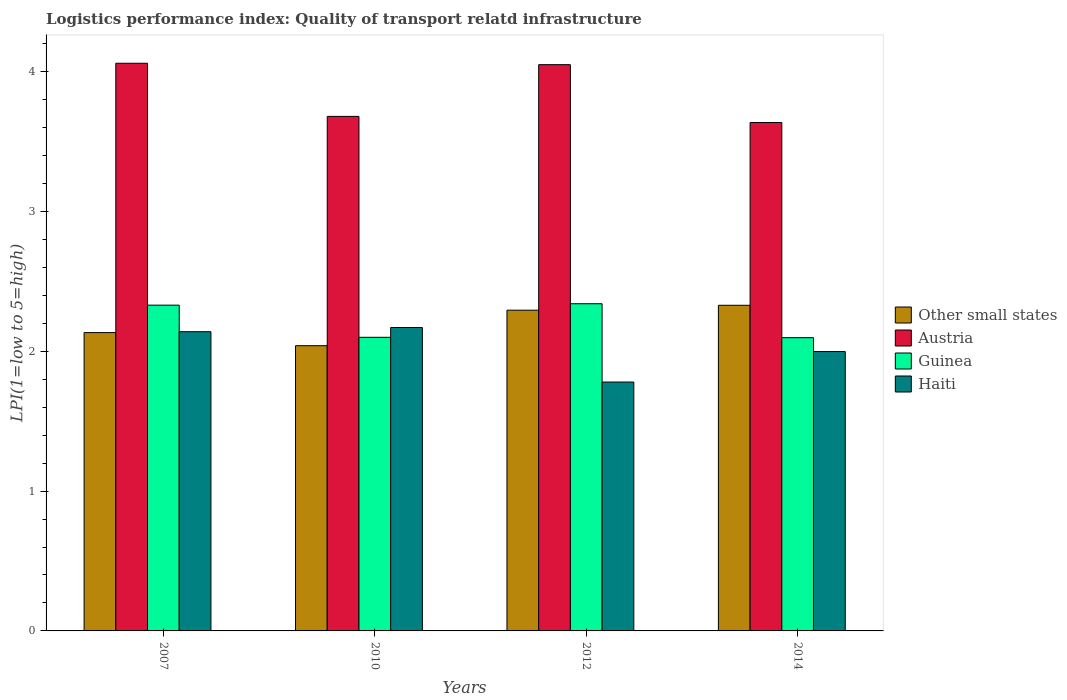How many different coloured bars are there?
Offer a very short reply. 4. How many groups of bars are there?
Keep it short and to the point. 4. Are the number of bars per tick equal to the number of legend labels?
Provide a short and direct response. Yes. Are the number of bars on each tick of the X-axis equal?
Offer a terse response. Yes. How many bars are there on the 4th tick from the left?
Offer a terse response. 4. What is the label of the 3rd group of bars from the left?
Make the answer very short. 2012. In how many cases, is the number of bars for a given year not equal to the number of legend labels?
Your response must be concise. 0. What is the logistics performance index in Austria in 2010?
Keep it short and to the point. 3.68. Across all years, what is the maximum logistics performance index in Austria?
Keep it short and to the point. 4.06. Across all years, what is the minimum logistics performance index in Haiti?
Give a very brief answer. 1.78. In which year was the logistics performance index in Austria maximum?
Give a very brief answer. 2007. What is the total logistics performance index in Austria in the graph?
Offer a terse response. 15.43. What is the difference between the logistics performance index in Other small states in 2007 and that in 2012?
Your answer should be very brief. -0.16. What is the difference between the logistics performance index in Haiti in 2007 and the logistics performance index in Other small states in 2010?
Your answer should be compact. 0.1. What is the average logistics performance index in Austria per year?
Your response must be concise. 3.86. In the year 2007, what is the difference between the logistics performance index in Guinea and logistics performance index in Haiti?
Offer a terse response. 0.19. In how many years, is the logistics performance index in Austria greater than 3.6?
Provide a succinct answer. 4. What is the ratio of the logistics performance index in Haiti in 2010 to that in 2012?
Your answer should be compact. 1.22. Is the logistics performance index in Haiti in 2007 less than that in 2012?
Your response must be concise. No. Is the difference between the logistics performance index in Guinea in 2010 and 2012 greater than the difference between the logistics performance index in Haiti in 2010 and 2012?
Offer a very short reply. No. What is the difference between the highest and the second highest logistics performance index in Haiti?
Provide a succinct answer. 0.03. What is the difference between the highest and the lowest logistics performance index in Haiti?
Offer a very short reply. 0.39. In how many years, is the logistics performance index in Haiti greater than the average logistics performance index in Haiti taken over all years?
Offer a terse response. 2. Is it the case that in every year, the sum of the logistics performance index in Haiti and logistics performance index in Guinea is greater than the sum of logistics performance index in Austria and logistics performance index in Other small states?
Your answer should be very brief. Yes. What does the 3rd bar from the left in 2010 represents?
Offer a very short reply. Guinea. What does the 1st bar from the right in 2014 represents?
Provide a short and direct response. Haiti. Is it the case that in every year, the sum of the logistics performance index in Guinea and logistics performance index in Haiti is greater than the logistics performance index in Other small states?
Give a very brief answer. Yes. Does the graph contain any zero values?
Your answer should be very brief. No. Where does the legend appear in the graph?
Provide a short and direct response. Center right. How many legend labels are there?
Make the answer very short. 4. How are the legend labels stacked?
Ensure brevity in your answer.  Vertical. What is the title of the graph?
Your answer should be very brief. Logistics performance index: Quality of transport relatd infrastructure. Does "Saudi Arabia" appear as one of the legend labels in the graph?
Offer a very short reply. No. What is the label or title of the Y-axis?
Your answer should be very brief. LPI(1=low to 5=high). What is the LPI(1=low to 5=high) of Other small states in 2007?
Make the answer very short. 2.13. What is the LPI(1=low to 5=high) in Austria in 2007?
Ensure brevity in your answer.  4.06. What is the LPI(1=low to 5=high) in Guinea in 2007?
Ensure brevity in your answer.  2.33. What is the LPI(1=low to 5=high) in Haiti in 2007?
Your answer should be compact. 2.14. What is the LPI(1=low to 5=high) in Other small states in 2010?
Your answer should be very brief. 2.04. What is the LPI(1=low to 5=high) in Austria in 2010?
Offer a very short reply. 3.68. What is the LPI(1=low to 5=high) in Haiti in 2010?
Keep it short and to the point. 2.17. What is the LPI(1=low to 5=high) of Other small states in 2012?
Offer a terse response. 2.29. What is the LPI(1=low to 5=high) in Austria in 2012?
Ensure brevity in your answer.  4.05. What is the LPI(1=low to 5=high) of Guinea in 2012?
Give a very brief answer. 2.34. What is the LPI(1=low to 5=high) in Haiti in 2012?
Offer a terse response. 1.78. What is the LPI(1=low to 5=high) in Other small states in 2014?
Keep it short and to the point. 2.33. What is the LPI(1=low to 5=high) in Austria in 2014?
Your answer should be very brief. 3.64. What is the LPI(1=low to 5=high) in Guinea in 2014?
Make the answer very short. 2.1. What is the LPI(1=low to 5=high) in Haiti in 2014?
Your response must be concise. 2. Across all years, what is the maximum LPI(1=low to 5=high) of Other small states?
Your response must be concise. 2.33. Across all years, what is the maximum LPI(1=low to 5=high) in Austria?
Give a very brief answer. 4.06. Across all years, what is the maximum LPI(1=low to 5=high) in Guinea?
Ensure brevity in your answer.  2.34. Across all years, what is the maximum LPI(1=low to 5=high) of Haiti?
Offer a very short reply. 2.17. Across all years, what is the minimum LPI(1=low to 5=high) of Other small states?
Provide a succinct answer. 2.04. Across all years, what is the minimum LPI(1=low to 5=high) in Austria?
Ensure brevity in your answer.  3.64. Across all years, what is the minimum LPI(1=low to 5=high) of Guinea?
Offer a terse response. 2.1. Across all years, what is the minimum LPI(1=low to 5=high) of Haiti?
Provide a short and direct response. 1.78. What is the total LPI(1=low to 5=high) in Other small states in the graph?
Offer a very short reply. 8.8. What is the total LPI(1=low to 5=high) of Austria in the graph?
Offer a terse response. 15.43. What is the total LPI(1=low to 5=high) in Guinea in the graph?
Ensure brevity in your answer.  8.87. What is the total LPI(1=low to 5=high) in Haiti in the graph?
Provide a short and direct response. 8.09. What is the difference between the LPI(1=low to 5=high) in Other small states in 2007 and that in 2010?
Your answer should be very brief. 0.09. What is the difference between the LPI(1=low to 5=high) of Austria in 2007 and that in 2010?
Offer a terse response. 0.38. What is the difference between the LPI(1=low to 5=high) of Guinea in 2007 and that in 2010?
Make the answer very short. 0.23. What is the difference between the LPI(1=low to 5=high) in Haiti in 2007 and that in 2010?
Offer a very short reply. -0.03. What is the difference between the LPI(1=low to 5=high) in Other small states in 2007 and that in 2012?
Your response must be concise. -0.16. What is the difference between the LPI(1=low to 5=high) of Austria in 2007 and that in 2012?
Ensure brevity in your answer.  0.01. What is the difference between the LPI(1=low to 5=high) of Guinea in 2007 and that in 2012?
Make the answer very short. -0.01. What is the difference between the LPI(1=low to 5=high) in Haiti in 2007 and that in 2012?
Provide a short and direct response. 0.36. What is the difference between the LPI(1=low to 5=high) of Other small states in 2007 and that in 2014?
Ensure brevity in your answer.  -0.2. What is the difference between the LPI(1=low to 5=high) in Austria in 2007 and that in 2014?
Provide a short and direct response. 0.42. What is the difference between the LPI(1=low to 5=high) in Guinea in 2007 and that in 2014?
Provide a succinct answer. 0.23. What is the difference between the LPI(1=low to 5=high) of Haiti in 2007 and that in 2014?
Give a very brief answer. 0.14. What is the difference between the LPI(1=low to 5=high) of Other small states in 2010 and that in 2012?
Your response must be concise. -0.25. What is the difference between the LPI(1=low to 5=high) of Austria in 2010 and that in 2012?
Ensure brevity in your answer.  -0.37. What is the difference between the LPI(1=low to 5=high) in Guinea in 2010 and that in 2012?
Your answer should be compact. -0.24. What is the difference between the LPI(1=low to 5=high) of Haiti in 2010 and that in 2012?
Your response must be concise. 0.39. What is the difference between the LPI(1=low to 5=high) in Other small states in 2010 and that in 2014?
Offer a very short reply. -0.29. What is the difference between the LPI(1=low to 5=high) of Austria in 2010 and that in 2014?
Keep it short and to the point. 0.04. What is the difference between the LPI(1=low to 5=high) of Guinea in 2010 and that in 2014?
Your answer should be very brief. 0. What is the difference between the LPI(1=low to 5=high) in Haiti in 2010 and that in 2014?
Your answer should be very brief. 0.17. What is the difference between the LPI(1=low to 5=high) of Other small states in 2012 and that in 2014?
Offer a very short reply. -0.04. What is the difference between the LPI(1=low to 5=high) in Austria in 2012 and that in 2014?
Provide a short and direct response. 0.41. What is the difference between the LPI(1=low to 5=high) in Guinea in 2012 and that in 2014?
Provide a short and direct response. 0.24. What is the difference between the LPI(1=low to 5=high) of Haiti in 2012 and that in 2014?
Give a very brief answer. -0.22. What is the difference between the LPI(1=low to 5=high) in Other small states in 2007 and the LPI(1=low to 5=high) in Austria in 2010?
Make the answer very short. -1.55. What is the difference between the LPI(1=low to 5=high) in Other small states in 2007 and the LPI(1=low to 5=high) in Guinea in 2010?
Your answer should be very brief. 0.03. What is the difference between the LPI(1=low to 5=high) in Other small states in 2007 and the LPI(1=low to 5=high) in Haiti in 2010?
Make the answer very short. -0.04. What is the difference between the LPI(1=low to 5=high) in Austria in 2007 and the LPI(1=low to 5=high) in Guinea in 2010?
Your response must be concise. 1.96. What is the difference between the LPI(1=low to 5=high) of Austria in 2007 and the LPI(1=low to 5=high) of Haiti in 2010?
Your response must be concise. 1.89. What is the difference between the LPI(1=low to 5=high) in Guinea in 2007 and the LPI(1=low to 5=high) in Haiti in 2010?
Keep it short and to the point. 0.16. What is the difference between the LPI(1=low to 5=high) in Other small states in 2007 and the LPI(1=low to 5=high) in Austria in 2012?
Make the answer very short. -1.92. What is the difference between the LPI(1=low to 5=high) of Other small states in 2007 and the LPI(1=low to 5=high) of Guinea in 2012?
Offer a terse response. -0.21. What is the difference between the LPI(1=low to 5=high) of Other small states in 2007 and the LPI(1=low to 5=high) of Haiti in 2012?
Provide a short and direct response. 0.35. What is the difference between the LPI(1=low to 5=high) in Austria in 2007 and the LPI(1=low to 5=high) in Guinea in 2012?
Offer a very short reply. 1.72. What is the difference between the LPI(1=low to 5=high) in Austria in 2007 and the LPI(1=low to 5=high) in Haiti in 2012?
Your answer should be very brief. 2.28. What is the difference between the LPI(1=low to 5=high) of Guinea in 2007 and the LPI(1=low to 5=high) of Haiti in 2012?
Offer a terse response. 0.55. What is the difference between the LPI(1=low to 5=high) in Other small states in 2007 and the LPI(1=low to 5=high) in Austria in 2014?
Provide a succinct answer. -1.5. What is the difference between the LPI(1=low to 5=high) of Other small states in 2007 and the LPI(1=low to 5=high) of Guinea in 2014?
Make the answer very short. 0.04. What is the difference between the LPI(1=low to 5=high) of Other small states in 2007 and the LPI(1=low to 5=high) of Haiti in 2014?
Give a very brief answer. 0.14. What is the difference between the LPI(1=low to 5=high) in Austria in 2007 and the LPI(1=low to 5=high) in Guinea in 2014?
Your answer should be very brief. 1.96. What is the difference between the LPI(1=low to 5=high) in Austria in 2007 and the LPI(1=low to 5=high) in Haiti in 2014?
Ensure brevity in your answer.  2.06. What is the difference between the LPI(1=low to 5=high) of Guinea in 2007 and the LPI(1=low to 5=high) of Haiti in 2014?
Your answer should be compact. 0.33. What is the difference between the LPI(1=low to 5=high) of Other small states in 2010 and the LPI(1=low to 5=high) of Austria in 2012?
Your answer should be compact. -2.01. What is the difference between the LPI(1=low to 5=high) in Other small states in 2010 and the LPI(1=low to 5=high) in Guinea in 2012?
Your answer should be compact. -0.3. What is the difference between the LPI(1=low to 5=high) of Other small states in 2010 and the LPI(1=low to 5=high) of Haiti in 2012?
Your response must be concise. 0.26. What is the difference between the LPI(1=low to 5=high) in Austria in 2010 and the LPI(1=low to 5=high) in Guinea in 2012?
Your response must be concise. 1.34. What is the difference between the LPI(1=low to 5=high) of Austria in 2010 and the LPI(1=low to 5=high) of Haiti in 2012?
Ensure brevity in your answer.  1.9. What is the difference between the LPI(1=low to 5=high) of Guinea in 2010 and the LPI(1=low to 5=high) of Haiti in 2012?
Provide a short and direct response. 0.32. What is the difference between the LPI(1=low to 5=high) in Other small states in 2010 and the LPI(1=low to 5=high) in Austria in 2014?
Your response must be concise. -1.6. What is the difference between the LPI(1=low to 5=high) of Other small states in 2010 and the LPI(1=low to 5=high) of Guinea in 2014?
Offer a terse response. -0.06. What is the difference between the LPI(1=low to 5=high) in Other small states in 2010 and the LPI(1=low to 5=high) in Haiti in 2014?
Provide a succinct answer. 0.04. What is the difference between the LPI(1=low to 5=high) in Austria in 2010 and the LPI(1=low to 5=high) in Guinea in 2014?
Offer a terse response. 1.58. What is the difference between the LPI(1=low to 5=high) of Austria in 2010 and the LPI(1=low to 5=high) of Haiti in 2014?
Provide a short and direct response. 1.68. What is the difference between the LPI(1=low to 5=high) of Guinea in 2010 and the LPI(1=low to 5=high) of Haiti in 2014?
Make the answer very short. 0.1. What is the difference between the LPI(1=low to 5=high) in Other small states in 2012 and the LPI(1=low to 5=high) in Austria in 2014?
Your answer should be very brief. -1.34. What is the difference between the LPI(1=low to 5=high) in Other small states in 2012 and the LPI(1=low to 5=high) in Guinea in 2014?
Make the answer very short. 0.2. What is the difference between the LPI(1=low to 5=high) in Other small states in 2012 and the LPI(1=low to 5=high) in Haiti in 2014?
Give a very brief answer. 0.3. What is the difference between the LPI(1=low to 5=high) in Austria in 2012 and the LPI(1=low to 5=high) in Guinea in 2014?
Make the answer very short. 1.95. What is the difference between the LPI(1=low to 5=high) of Austria in 2012 and the LPI(1=low to 5=high) of Haiti in 2014?
Your answer should be compact. 2.05. What is the difference between the LPI(1=low to 5=high) in Guinea in 2012 and the LPI(1=low to 5=high) in Haiti in 2014?
Make the answer very short. 0.34. What is the average LPI(1=low to 5=high) of Other small states per year?
Your answer should be compact. 2.2. What is the average LPI(1=low to 5=high) in Austria per year?
Offer a terse response. 3.86. What is the average LPI(1=low to 5=high) of Guinea per year?
Provide a short and direct response. 2.22. What is the average LPI(1=low to 5=high) in Haiti per year?
Ensure brevity in your answer.  2.02. In the year 2007, what is the difference between the LPI(1=low to 5=high) in Other small states and LPI(1=low to 5=high) in Austria?
Ensure brevity in your answer.  -1.93. In the year 2007, what is the difference between the LPI(1=low to 5=high) in Other small states and LPI(1=low to 5=high) in Guinea?
Make the answer very short. -0.2. In the year 2007, what is the difference between the LPI(1=low to 5=high) in Other small states and LPI(1=low to 5=high) in Haiti?
Ensure brevity in your answer.  -0.01. In the year 2007, what is the difference between the LPI(1=low to 5=high) in Austria and LPI(1=low to 5=high) in Guinea?
Ensure brevity in your answer.  1.73. In the year 2007, what is the difference between the LPI(1=low to 5=high) in Austria and LPI(1=low to 5=high) in Haiti?
Provide a short and direct response. 1.92. In the year 2007, what is the difference between the LPI(1=low to 5=high) of Guinea and LPI(1=low to 5=high) of Haiti?
Your answer should be very brief. 0.19. In the year 2010, what is the difference between the LPI(1=low to 5=high) in Other small states and LPI(1=low to 5=high) in Austria?
Give a very brief answer. -1.64. In the year 2010, what is the difference between the LPI(1=low to 5=high) of Other small states and LPI(1=low to 5=high) of Guinea?
Your answer should be compact. -0.06. In the year 2010, what is the difference between the LPI(1=low to 5=high) of Other small states and LPI(1=low to 5=high) of Haiti?
Your response must be concise. -0.13. In the year 2010, what is the difference between the LPI(1=low to 5=high) in Austria and LPI(1=low to 5=high) in Guinea?
Your answer should be compact. 1.58. In the year 2010, what is the difference between the LPI(1=low to 5=high) of Austria and LPI(1=low to 5=high) of Haiti?
Offer a terse response. 1.51. In the year 2010, what is the difference between the LPI(1=low to 5=high) in Guinea and LPI(1=low to 5=high) in Haiti?
Offer a very short reply. -0.07. In the year 2012, what is the difference between the LPI(1=low to 5=high) in Other small states and LPI(1=low to 5=high) in Austria?
Keep it short and to the point. -1.76. In the year 2012, what is the difference between the LPI(1=low to 5=high) in Other small states and LPI(1=low to 5=high) in Guinea?
Make the answer very short. -0.05. In the year 2012, what is the difference between the LPI(1=low to 5=high) in Other small states and LPI(1=low to 5=high) in Haiti?
Your response must be concise. 0.51. In the year 2012, what is the difference between the LPI(1=low to 5=high) in Austria and LPI(1=low to 5=high) in Guinea?
Your response must be concise. 1.71. In the year 2012, what is the difference between the LPI(1=low to 5=high) in Austria and LPI(1=low to 5=high) in Haiti?
Your answer should be compact. 2.27. In the year 2012, what is the difference between the LPI(1=low to 5=high) in Guinea and LPI(1=low to 5=high) in Haiti?
Your response must be concise. 0.56. In the year 2014, what is the difference between the LPI(1=low to 5=high) in Other small states and LPI(1=low to 5=high) in Austria?
Give a very brief answer. -1.31. In the year 2014, what is the difference between the LPI(1=low to 5=high) in Other small states and LPI(1=low to 5=high) in Guinea?
Provide a succinct answer. 0.23. In the year 2014, what is the difference between the LPI(1=low to 5=high) in Other small states and LPI(1=low to 5=high) in Haiti?
Provide a succinct answer. 0.33. In the year 2014, what is the difference between the LPI(1=low to 5=high) of Austria and LPI(1=low to 5=high) of Guinea?
Provide a short and direct response. 1.54. In the year 2014, what is the difference between the LPI(1=low to 5=high) of Austria and LPI(1=low to 5=high) of Haiti?
Your response must be concise. 1.64. In the year 2014, what is the difference between the LPI(1=low to 5=high) in Guinea and LPI(1=low to 5=high) in Haiti?
Provide a succinct answer. 0.1. What is the ratio of the LPI(1=low to 5=high) in Other small states in 2007 to that in 2010?
Keep it short and to the point. 1.05. What is the ratio of the LPI(1=low to 5=high) in Austria in 2007 to that in 2010?
Offer a very short reply. 1.1. What is the ratio of the LPI(1=low to 5=high) of Guinea in 2007 to that in 2010?
Make the answer very short. 1.11. What is the ratio of the LPI(1=low to 5=high) of Haiti in 2007 to that in 2010?
Offer a terse response. 0.99. What is the ratio of the LPI(1=low to 5=high) in Other small states in 2007 to that in 2012?
Offer a terse response. 0.93. What is the ratio of the LPI(1=low to 5=high) in Guinea in 2007 to that in 2012?
Make the answer very short. 1. What is the ratio of the LPI(1=low to 5=high) in Haiti in 2007 to that in 2012?
Give a very brief answer. 1.2. What is the ratio of the LPI(1=low to 5=high) of Other small states in 2007 to that in 2014?
Offer a very short reply. 0.92. What is the ratio of the LPI(1=low to 5=high) of Austria in 2007 to that in 2014?
Your response must be concise. 1.12. What is the ratio of the LPI(1=low to 5=high) of Guinea in 2007 to that in 2014?
Make the answer very short. 1.11. What is the ratio of the LPI(1=low to 5=high) in Haiti in 2007 to that in 2014?
Make the answer very short. 1.07. What is the ratio of the LPI(1=low to 5=high) of Other small states in 2010 to that in 2012?
Your answer should be compact. 0.89. What is the ratio of the LPI(1=low to 5=high) of Austria in 2010 to that in 2012?
Keep it short and to the point. 0.91. What is the ratio of the LPI(1=low to 5=high) of Guinea in 2010 to that in 2012?
Ensure brevity in your answer.  0.9. What is the ratio of the LPI(1=low to 5=high) in Haiti in 2010 to that in 2012?
Your response must be concise. 1.22. What is the ratio of the LPI(1=low to 5=high) of Other small states in 2010 to that in 2014?
Your answer should be very brief. 0.88. What is the ratio of the LPI(1=low to 5=high) of Austria in 2010 to that in 2014?
Make the answer very short. 1.01. What is the ratio of the LPI(1=low to 5=high) in Haiti in 2010 to that in 2014?
Your answer should be compact. 1.09. What is the ratio of the LPI(1=low to 5=high) of Other small states in 2012 to that in 2014?
Keep it short and to the point. 0.98. What is the ratio of the LPI(1=low to 5=high) in Austria in 2012 to that in 2014?
Your answer should be compact. 1.11. What is the ratio of the LPI(1=low to 5=high) in Guinea in 2012 to that in 2014?
Your response must be concise. 1.12. What is the ratio of the LPI(1=low to 5=high) in Haiti in 2012 to that in 2014?
Your answer should be very brief. 0.89. What is the difference between the highest and the second highest LPI(1=low to 5=high) of Other small states?
Provide a short and direct response. 0.04. What is the difference between the highest and the lowest LPI(1=low to 5=high) of Other small states?
Provide a succinct answer. 0.29. What is the difference between the highest and the lowest LPI(1=low to 5=high) of Austria?
Make the answer very short. 0.42. What is the difference between the highest and the lowest LPI(1=low to 5=high) of Guinea?
Offer a very short reply. 0.24. What is the difference between the highest and the lowest LPI(1=low to 5=high) in Haiti?
Ensure brevity in your answer.  0.39. 